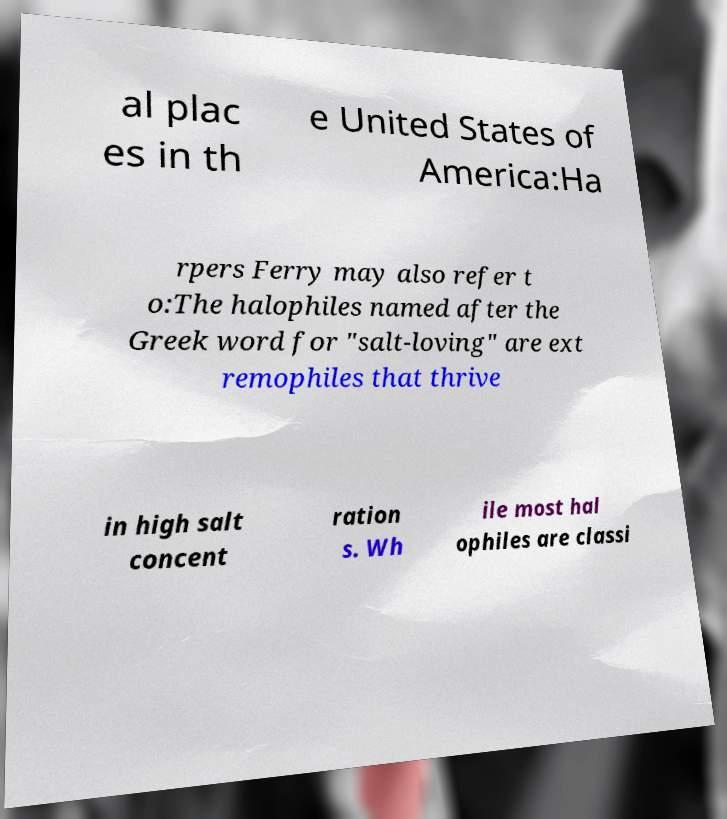For documentation purposes, I need the text within this image transcribed. Could you provide that? al plac es in th e United States of America:Ha rpers Ferry may also refer t o:The halophiles named after the Greek word for "salt-loving" are ext remophiles that thrive in high salt concent ration s. Wh ile most hal ophiles are classi 